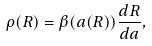<formula> <loc_0><loc_0><loc_500><loc_500>\rho ( R ) = \beta ( a ( R ) ) \frac { d R } { d a } ,</formula> 